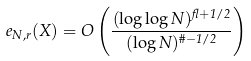Convert formula to latex. <formula><loc_0><loc_0><loc_500><loc_500>e _ { N , r } ( X ) = O \left ( \frac { ( \log \log N ) ^ { \gamma + 1 / 2 } } { ( \log N ) ^ { \vartheta - 1 / 2 } } \right )</formula> 